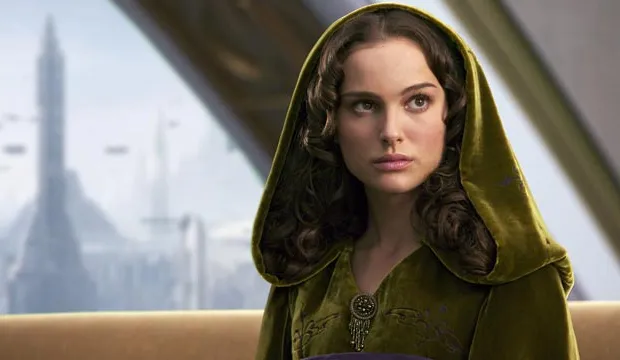Describe the mood conveyed by the setting in the background. The background setting, featuring an expansive view of a futuristic cityscape with towering buildings and airborne vehicles, conveys a mood of vibrant, technological advancement. The blend of clear skies and the bustling urban environment suggests a thriving, dynamic society. Additionally, the juxtaposition of such a modern backdrop against the character's traditional attire may evoke a sense of timelessness or an underlying tension between the old and the new, reflecting the complexities of the world she inhabits. 